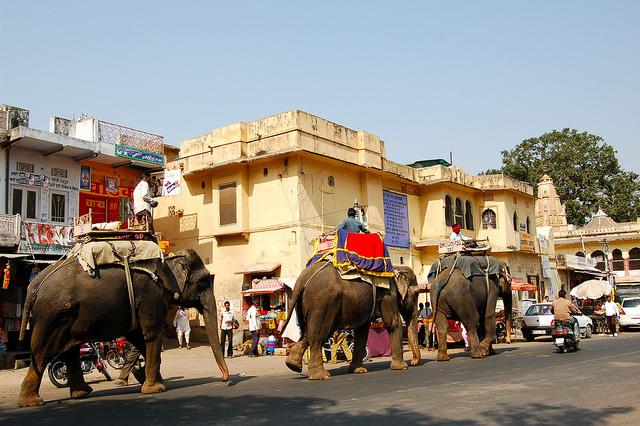Which mode of transport in use here uses less gasoline? Please explain your reasoning. elephants. The transportation is the elephants. 